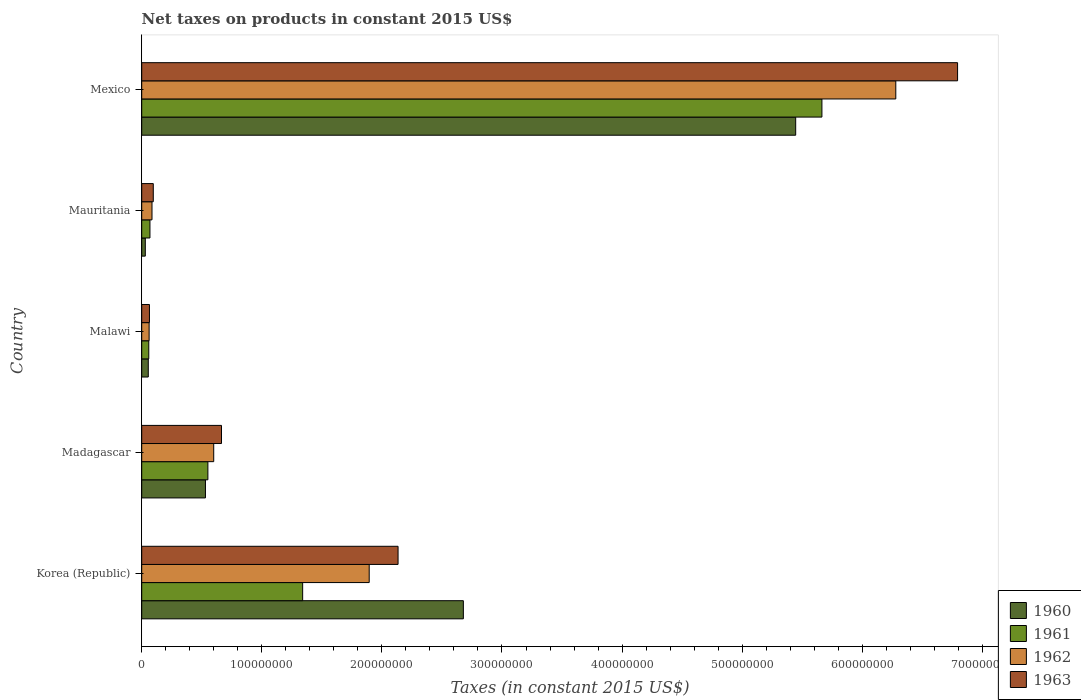How many groups of bars are there?
Ensure brevity in your answer.  5. Are the number of bars per tick equal to the number of legend labels?
Offer a very short reply. Yes. What is the label of the 4th group of bars from the top?
Your answer should be very brief. Madagascar. What is the net taxes on products in 1963 in Mexico?
Keep it short and to the point. 6.79e+08. Across all countries, what is the maximum net taxes on products in 1960?
Keep it short and to the point. 5.45e+08. Across all countries, what is the minimum net taxes on products in 1962?
Your answer should be very brief. 6.16e+06. In which country was the net taxes on products in 1963 minimum?
Offer a very short reply. Malawi. What is the total net taxes on products in 1961 in the graph?
Give a very brief answer. 7.68e+08. What is the difference between the net taxes on products in 1962 in Korea (Republic) and that in Mauritania?
Your answer should be very brief. 1.81e+08. What is the difference between the net taxes on products in 1961 in Korea (Republic) and the net taxes on products in 1962 in Madagascar?
Offer a terse response. 7.41e+07. What is the average net taxes on products in 1962 per country?
Make the answer very short. 1.78e+08. What is the difference between the net taxes on products in 1960 and net taxes on products in 1961 in Mexico?
Your response must be concise. -2.18e+07. In how many countries, is the net taxes on products in 1960 greater than 400000000 US$?
Your answer should be compact. 1. What is the ratio of the net taxes on products in 1962 in Korea (Republic) to that in Mexico?
Ensure brevity in your answer.  0.3. Is the net taxes on products in 1963 in Malawi less than that in Mexico?
Provide a short and direct response. Yes. Is the difference between the net taxes on products in 1960 in Korea (Republic) and Madagascar greater than the difference between the net taxes on products in 1961 in Korea (Republic) and Madagascar?
Offer a very short reply. Yes. What is the difference between the highest and the second highest net taxes on products in 1960?
Make the answer very short. 2.77e+08. What is the difference between the highest and the lowest net taxes on products in 1962?
Offer a very short reply. 6.22e+08. Is it the case that in every country, the sum of the net taxes on products in 1962 and net taxes on products in 1963 is greater than the sum of net taxes on products in 1960 and net taxes on products in 1961?
Your response must be concise. No. What does the 2nd bar from the top in Mexico represents?
Your answer should be compact. 1962. Is it the case that in every country, the sum of the net taxes on products in 1960 and net taxes on products in 1963 is greater than the net taxes on products in 1962?
Provide a short and direct response. Yes. Are all the bars in the graph horizontal?
Provide a short and direct response. Yes. How many countries are there in the graph?
Keep it short and to the point. 5. What is the difference between two consecutive major ticks on the X-axis?
Keep it short and to the point. 1.00e+08. What is the title of the graph?
Provide a succinct answer. Net taxes on products in constant 2015 US$. Does "1990" appear as one of the legend labels in the graph?
Make the answer very short. No. What is the label or title of the X-axis?
Ensure brevity in your answer.  Taxes (in constant 2015 US$). What is the label or title of the Y-axis?
Provide a short and direct response. Country. What is the Taxes (in constant 2015 US$) of 1960 in Korea (Republic)?
Give a very brief answer. 2.68e+08. What is the Taxes (in constant 2015 US$) in 1961 in Korea (Republic)?
Your answer should be very brief. 1.34e+08. What is the Taxes (in constant 2015 US$) in 1962 in Korea (Republic)?
Give a very brief answer. 1.89e+08. What is the Taxes (in constant 2015 US$) of 1963 in Korea (Republic)?
Your response must be concise. 2.13e+08. What is the Taxes (in constant 2015 US$) in 1960 in Madagascar?
Provide a short and direct response. 5.31e+07. What is the Taxes (in constant 2015 US$) in 1961 in Madagascar?
Make the answer very short. 5.51e+07. What is the Taxes (in constant 2015 US$) in 1962 in Madagascar?
Your answer should be very brief. 6.00e+07. What is the Taxes (in constant 2015 US$) of 1963 in Madagascar?
Give a very brief answer. 6.64e+07. What is the Taxes (in constant 2015 US$) of 1960 in Malawi?
Give a very brief answer. 5.46e+06. What is the Taxes (in constant 2015 US$) of 1961 in Malawi?
Your answer should be compact. 5.88e+06. What is the Taxes (in constant 2015 US$) of 1962 in Malawi?
Make the answer very short. 6.16e+06. What is the Taxes (in constant 2015 US$) of 1963 in Malawi?
Offer a very short reply. 6.44e+06. What is the Taxes (in constant 2015 US$) of 1960 in Mauritania?
Provide a short and direct response. 3.00e+06. What is the Taxes (in constant 2015 US$) in 1961 in Mauritania?
Your answer should be very brief. 6.85e+06. What is the Taxes (in constant 2015 US$) in 1962 in Mauritania?
Your answer should be very brief. 8.56e+06. What is the Taxes (in constant 2015 US$) in 1963 in Mauritania?
Give a very brief answer. 9.63e+06. What is the Taxes (in constant 2015 US$) of 1960 in Mexico?
Your response must be concise. 5.45e+08. What is the Taxes (in constant 2015 US$) in 1961 in Mexico?
Ensure brevity in your answer.  5.66e+08. What is the Taxes (in constant 2015 US$) of 1962 in Mexico?
Give a very brief answer. 6.28e+08. What is the Taxes (in constant 2015 US$) of 1963 in Mexico?
Give a very brief answer. 6.79e+08. Across all countries, what is the maximum Taxes (in constant 2015 US$) in 1960?
Make the answer very short. 5.45e+08. Across all countries, what is the maximum Taxes (in constant 2015 US$) in 1961?
Your answer should be compact. 5.66e+08. Across all countries, what is the maximum Taxes (in constant 2015 US$) of 1962?
Make the answer very short. 6.28e+08. Across all countries, what is the maximum Taxes (in constant 2015 US$) in 1963?
Provide a succinct answer. 6.79e+08. Across all countries, what is the minimum Taxes (in constant 2015 US$) in 1960?
Offer a terse response. 3.00e+06. Across all countries, what is the minimum Taxes (in constant 2015 US$) of 1961?
Ensure brevity in your answer.  5.88e+06. Across all countries, what is the minimum Taxes (in constant 2015 US$) of 1962?
Give a very brief answer. 6.16e+06. Across all countries, what is the minimum Taxes (in constant 2015 US$) in 1963?
Offer a terse response. 6.44e+06. What is the total Taxes (in constant 2015 US$) in 1960 in the graph?
Provide a succinct answer. 8.74e+08. What is the total Taxes (in constant 2015 US$) in 1961 in the graph?
Your answer should be very brief. 7.68e+08. What is the total Taxes (in constant 2015 US$) of 1962 in the graph?
Provide a succinct answer. 8.92e+08. What is the total Taxes (in constant 2015 US$) of 1963 in the graph?
Provide a short and direct response. 9.75e+08. What is the difference between the Taxes (in constant 2015 US$) in 1960 in Korea (Republic) and that in Madagascar?
Give a very brief answer. 2.15e+08. What is the difference between the Taxes (in constant 2015 US$) in 1961 in Korea (Republic) and that in Madagascar?
Give a very brief answer. 7.89e+07. What is the difference between the Taxes (in constant 2015 US$) of 1962 in Korea (Republic) and that in Madagascar?
Offer a very short reply. 1.29e+08. What is the difference between the Taxes (in constant 2015 US$) of 1963 in Korea (Republic) and that in Madagascar?
Provide a short and direct response. 1.47e+08. What is the difference between the Taxes (in constant 2015 US$) in 1960 in Korea (Republic) and that in Malawi?
Your response must be concise. 2.62e+08. What is the difference between the Taxes (in constant 2015 US$) of 1961 in Korea (Republic) and that in Malawi?
Ensure brevity in your answer.  1.28e+08. What is the difference between the Taxes (in constant 2015 US$) in 1962 in Korea (Republic) and that in Malawi?
Offer a very short reply. 1.83e+08. What is the difference between the Taxes (in constant 2015 US$) of 1963 in Korea (Republic) and that in Malawi?
Give a very brief answer. 2.07e+08. What is the difference between the Taxes (in constant 2015 US$) of 1960 in Korea (Republic) and that in Mauritania?
Offer a terse response. 2.65e+08. What is the difference between the Taxes (in constant 2015 US$) in 1961 in Korea (Republic) and that in Mauritania?
Provide a short and direct response. 1.27e+08. What is the difference between the Taxes (in constant 2015 US$) in 1962 in Korea (Republic) and that in Mauritania?
Offer a terse response. 1.81e+08. What is the difference between the Taxes (in constant 2015 US$) in 1963 in Korea (Republic) and that in Mauritania?
Ensure brevity in your answer.  2.04e+08. What is the difference between the Taxes (in constant 2015 US$) in 1960 in Korea (Republic) and that in Mexico?
Ensure brevity in your answer.  -2.77e+08. What is the difference between the Taxes (in constant 2015 US$) of 1961 in Korea (Republic) and that in Mexico?
Your response must be concise. -4.32e+08. What is the difference between the Taxes (in constant 2015 US$) in 1962 in Korea (Republic) and that in Mexico?
Offer a terse response. -4.38e+08. What is the difference between the Taxes (in constant 2015 US$) in 1963 in Korea (Republic) and that in Mexico?
Ensure brevity in your answer.  -4.66e+08. What is the difference between the Taxes (in constant 2015 US$) of 1960 in Madagascar and that in Malawi?
Keep it short and to the point. 4.76e+07. What is the difference between the Taxes (in constant 2015 US$) in 1961 in Madagascar and that in Malawi?
Ensure brevity in your answer.  4.92e+07. What is the difference between the Taxes (in constant 2015 US$) of 1962 in Madagascar and that in Malawi?
Your response must be concise. 5.38e+07. What is the difference between the Taxes (in constant 2015 US$) in 1963 in Madagascar and that in Malawi?
Offer a terse response. 6.00e+07. What is the difference between the Taxes (in constant 2015 US$) in 1960 in Madagascar and that in Mauritania?
Make the answer very short. 5.01e+07. What is the difference between the Taxes (in constant 2015 US$) in 1961 in Madagascar and that in Mauritania?
Give a very brief answer. 4.82e+07. What is the difference between the Taxes (in constant 2015 US$) of 1962 in Madagascar and that in Mauritania?
Your answer should be compact. 5.14e+07. What is the difference between the Taxes (in constant 2015 US$) of 1963 in Madagascar and that in Mauritania?
Offer a terse response. 5.68e+07. What is the difference between the Taxes (in constant 2015 US$) in 1960 in Madagascar and that in Mexico?
Offer a terse response. -4.91e+08. What is the difference between the Taxes (in constant 2015 US$) of 1961 in Madagascar and that in Mexico?
Your response must be concise. -5.11e+08. What is the difference between the Taxes (in constant 2015 US$) in 1962 in Madagascar and that in Mexico?
Your answer should be compact. -5.68e+08. What is the difference between the Taxes (in constant 2015 US$) of 1963 in Madagascar and that in Mexico?
Ensure brevity in your answer.  -6.13e+08. What is the difference between the Taxes (in constant 2015 US$) in 1960 in Malawi and that in Mauritania?
Give a very brief answer. 2.46e+06. What is the difference between the Taxes (in constant 2015 US$) in 1961 in Malawi and that in Mauritania?
Offer a very short reply. -9.67e+05. What is the difference between the Taxes (in constant 2015 US$) in 1962 in Malawi and that in Mauritania?
Your answer should be compact. -2.40e+06. What is the difference between the Taxes (in constant 2015 US$) in 1963 in Malawi and that in Mauritania?
Provide a short and direct response. -3.19e+06. What is the difference between the Taxes (in constant 2015 US$) in 1960 in Malawi and that in Mexico?
Ensure brevity in your answer.  -5.39e+08. What is the difference between the Taxes (in constant 2015 US$) in 1961 in Malawi and that in Mexico?
Make the answer very short. -5.61e+08. What is the difference between the Taxes (in constant 2015 US$) of 1962 in Malawi and that in Mexico?
Give a very brief answer. -6.22e+08. What is the difference between the Taxes (in constant 2015 US$) of 1963 in Malawi and that in Mexico?
Your answer should be very brief. -6.73e+08. What is the difference between the Taxes (in constant 2015 US$) in 1960 in Mauritania and that in Mexico?
Give a very brief answer. -5.42e+08. What is the difference between the Taxes (in constant 2015 US$) of 1961 in Mauritania and that in Mexico?
Your answer should be very brief. -5.60e+08. What is the difference between the Taxes (in constant 2015 US$) in 1962 in Mauritania and that in Mexico?
Your response must be concise. -6.19e+08. What is the difference between the Taxes (in constant 2015 US$) of 1963 in Mauritania and that in Mexico?
Provide a succinct answer. -6.70e+08. What is the difference between the Taxes (in constant 2015 US$) of 1960 in Korea (Republic) and the Taxes (in constant 2015 US$) of 1961 in Madagascar?
Ensure brevity in your answer.  2.13e+08. What is the difference between the Taxes (in constant 2015 US$) in 1960 in Korea (Republic) and the Taxes (in constant 2015 US$) in 1962 in Madagascar?
Your response must be concise. 2.08e+08. What is the difference between the Taxes (in constant 2015 US$) in 1960 in Korea (Republic) and the Taxes (in constant 2015 US$) in 1963 in Madagascar?
Keep it short and to the point. 2.01e+08. What is the difference between the Taxes (in constant 2015 US$) in 1961 in Korea (Republic) and the Taxes (in constant 2015 US$) in 1962 in Madagascar?
Provide a succinct answer. 7.41e+07. What is the difference between the Taxes (in constant 2015 US$) in 1961 in Korea (Republic) and the Taxes (in constant 2015 US$) in 1963 in Madagascar?
Ensure brevity in your answer.  6.76e+07. What is the difference between the Taxes (in constant 2015 US$) of 1962 in Korea (Republic) and the Taxes (in constant 2015 US$) of 1963 in Madagascar?
Your answer should be compact. 1.23e+08. What is the difference between the Taxes (in constant 2015 US$) of 1960 in Korea (Republic) and the Taxes (in constant 2015 US$) of 1961 in Malawi?
Offer a very short reply. 2.62e+08. What is the difference between the Taxes (in constant 2015 US$) in 1960 in Korea (Republic) and the Taxes (in constant 2015 US$) in 1962 in Malawi?
Offer a very short reply. 2.62e+08. What is the difference between the Taxes (in constant 2015 US$) in 1960 in Korea (Republic) and the Taxes (in constant 2015 US$) in 1963 in Malawi?
Your answer should be compact. 2.61e+08. What is the difference between the Taxes (in constant 2015 US$) in 1961 in Korea (Republic) and the Taxes (in constant 2015 US$) in 1962 in Malawi?
Your answer should be very brief. 1.28e+08. What is the difference between the Taxes (in constant 2015 US$) of 1961 in Korea (Republic) and the Taxes (in constant 2015 US$) of 1963 in Malawi?
Provide a succinct answer. 1.28e+08. What is the difference between the Taxes (in constant 2015 US$) in 1962 in Korea (Republic) and the Taxes (in constant 2015 US$) in 1963 in Malawi?
Offer a very short reply. 1.83e+08. What is the difference between the Taxes (in constant 2015 US$) of 1960 in Korea (Republic) and the Taxes (in constant 2015 US$) of 1961 in Mauritania?
Provide a succinct answer. 2.61e+08. What is the difference between the Taxes (in constant 2015 US$) of 1960 in Korea (Republic) and the Taxes (in constant 2015 US$) of 1962 in Mauritania?
Provide a short and direct response. 2.59e+08. What is the difference between the Taxes (in constant 2015 US$) in 1960 in Korea (Republic) and the Taxes (in constant 2015 US$) in 1963 in Mauritania?
Your answer should be compact. 2.58e+08. What is the difference between the Taxes (in constant 2015 US$) in 1961 in Korea (Republic) and the Taxes (in constant 2015 US$) in 1962 in Mauritania?
Offer a terse response. 1.25e+08. What is the difference between the Taxes (in constant 2015 US$) in 1961 in Korea (Republic) and the Taxes (in constant 2015 US$) in 1963 in Mauritania?
Offer a very short reply. 1.24e+08. What is the difference between the Taxes (in constant 2015 US$) of 1962 in Korea (Republic) and the Taxes (in constant 2015 US$) of 1963 in Mauritania?
Your response must be concise. 1.80e+08. What is the difference between the Taxes (in constant 2015 US$) in 1960 in Korea (Republic) and the Taxes (in constant 2015 US$) in 1961 in Mexico?
Provide a succinct answer. -2.99e+08. What is the difference between the Taxes (in constant 2015 US$) in 1960 in Korea (Republic) and the Taxes (in constant 2015 US$) in 1962 in Mexico?
Offer a terse response. -3.60e+08. What is the difference between the Taxes (in constant 2015 US$) in 1960 in Korea (Republic) and the Taxes (in constant 2015 US$) in 1963 in Mexico?
Offer a very short reply. -4.12e+08. What is the difference between the Taxes (in constant 2015 US$) of 1961 in Korea (Republic) and the Taxes (in constant 2015 US$) of 1962 in Mexico?
Keep it short and to the point. -4.94e+08. What is the difference between the Taxes (in constant 2015 US$) of 1961 in Korea (Republic) and the Taxes (in constant 2015 US$) of 1963 in Mexico?
Your response must be concise. -5.45e+08. What is the difference between the Taxes (in constant 2015 US$) in 1962 in Korea (Republic) and the Taxes (in constant 2015 US$) in 1963 in Mexico?
Your response must be concise. -4.90e+08. What is the difference between the Taxes (in constant 2015 US$) of 1960 in Madagascar and the Taxes (in constant 2015 US$) of 1961 in Malawi?
Give a very brief answer. 4.72e+07. What is the difference between the Taxes (in constant 2015 US$) of 1960 in Madagascar and the Taxes (in constant 2015 US$) of 1962 in Malawi?
Keep it short and to the point. 4.69e+07. What is the difference between the Taxes (in constant 2015 US$) of 1960 in Madagascar and the Taxes (in constant 2015 US$) of 1963 in Malawi?
Provide a short and direct response. 4.66e+07. What is the difference between the Taxes (in constant 2015 US$) of 1961 in Madagascar and the Taxes (in constant 2015 US$) of 1962 in Malawi?
Your answer should be compact. 4.89e+07. What is the difference between the Taxes (in constant 2015 US$) in 1961 in Madagascar and the Taxes (in constant 2015 US$) in 1963 in Malawi?
Make the answer very short. 4.87e+07. What is the difference between the Taxes (in constant 2015 US$) of 1962 in Madagascar and the Taxes (in constant 2015 US$) of 1963 in Malawi?
Your response must be concise. 5.35e+07. What is the difference between the Taxes (in constant 2015 US$) of 1960 in Madagascar and the Taxes (in constant 2015 US$) of 1961 in Mauritania?
Provide a succinct answer. 4.62e+07. What is the difference between the Taxes (in constant 2015 US$) of 1960 in Madagascar and the Taxes (in constant 2015 US$) of 1962 in Mauritania?
Ensure brevity in your answer.  4.45e+07. What is the difference between the Taxes (in constant 2015 US$) of 1960 in Madagascar and the Taxes (in constant 2015 US$) of 1963 in Mauritania?
Your response must be concise. 4.34e+07. What is the difference between the Taxes (in constant 2015 US$) of 1961 in Madagascar and the Taxes (in constant 2015 US$) of 1962 in Mauritania?
Your response must be concise. 4.65e+07. What is the difference between the Taxes (in constant 2015 US$) in 1961 in Madagascar and the Taxes (in constant 2015 US$) in 1963 in Mauritania?
Your response must be concise. 4.55e+07. What is the difference between the Taxes (in constant 2015 US$) of 1962 in Madagascar and the Taxes (in constant 2015 US$) of 1963 in Mauritania?
Your response must be concise. 5.03e+07. What is the difference between the Taxes (in constant 2015 US$) in 1960 in Madagascar and the Taxes (in constant 2015 US$) in 1961 in Mexico?
Give a very brief answer. -5.13e+08. What is the difference between the Taxes (in constant 2015 US$) in 1960 in Madagascar and the Taxes (in constant 2015 US$) in 1962 in Mexico?
Ensure brevity in your answer.  -5.75e+08. What is the difference between the Taxes (in constant 2015 US$) in 1960 in Madagascar and the Taxes (in constant 2015 US$) in 1963 in Mexico?
Your answer should be compact. -6.26e+08. What is the difference between the Taxes (in constant 2015 US$) of 1961 in Madagascar and the Taxes (in constant 2015 US$) of 1962 in Mexico?
Provide a short and direct response. -5.73e+08. What is the difference between the Taxes (in constant 2015 US$) in 1961 in Madagascar and the Taxes (in constant 2015 US$) in 1963 in Mexico?
Offer a very short reply. -6.24e+08. What is the difference between the Taxes (in constant 2015 US$) in 1962 in Madagascar and the Taxes (in constant 2015 US$) in 1963 in Mexico?
Keep it short and to the point. -6.19e+08. What is the difference between the Taxes (in constant 2015 US$) in 1960 in Malawi and the Taxes (in constant 2015 US$) in 1961 in Mauritania?
Ensure brevity in your answer.  -1.39e+06. What is the difference between the Taxes (in constant 2015 US$) in 1960 in Malawi and the Taxes (in constant 2015 US$) in 1962 in Mauritania?
Keep it short and to the point. -3.10e+06. What is the difference between the Taxes (in constant 2015 US$) in 1960 in Malawi and the Taxes (in constant 2015 US$) in 1963 in Mauritania?
Offer a very short reply. -4.17e+06. What is the difference between the Taxes (in constant 2015 US$) of 1961 in Malawi and the Taxes (in constant 2015 US$) of 1962 in Mauritania?
Offer a very short reply. -2.68e+06. What is the difference between the Taxes (in constant 2015 US$) in 1961 in Malawi and the Taxes (in constant 2015 US$) in 1963 in Mauritania?
Your answer should be very brief. -3.75e+06. What is the difference between the Taxes (in constant 2015 US$) in 1962 in Malawi and the Taxes (in constant 2015 US$) in 1963 in Mauritania?
Keep it short and to the point. -3.47e+06. What is the difference between the Taxes (in constant 2015 US$) in 1960 in Malawi and the Taxes (in constant 2015 US$) in 1961 in Mexico?
Your answer should be very brief. -5.61e+08. What is the difference between the Taxes (in constant 2015 US$) in 1960 in Malawi and the Taxes (in constant 2015 US$) in 1962 in Mexico?
Offer a terse response. -6.22e+08. What is the difference between the Taxes (in constant 2015 US$) of 1960 in Malawi and the Taxes (in constant 2015 US$) of 1963 in Mexico?
Keep it short and to the point. -6.74e+08. What is the difference between the Taxes (in constant 2015 US$) in 1961 in Malawi and the Taxes (in constant 2015 US$) in 1962 in Mexico?
Make the answer very short. -6.22e+08. What is the difference between the Taxes (in constant 2015 US$) of 1961 in Malawi and the Taxes (in constant 2015 US$) of 1963 in Mexico?
Offer a terse response. -6.73e+08. What is the difference between the Taxes (in constant 2015 US$) in 1962 in Malawi and the Taxes (in constant 2015 US$) in 1963 in Mexico?
Ensure brevity in your answer.  -6.73e+08. What is the difference between the Taxes (in constant 2015 US$) of 1960 in Mauritania and the Taxes (in constant 2015 US$) of 1961 in Mexico?
Offer a very short reply. -5.63e+08. What is the difference between the Taxes (in constant 2015 US$) in 1960 in Mauritania and the Taxes (in constant 2015 US$) in 1962 in Mexico?
Provide a short and direct response. -6.25e+08. What is the difference between the Taxes (in constant 2015 US$) of 1960 in Mauritania and the Taxes (in constant 2015 US$) of 1963 in Mexico?
Provide a succinct answer. -6.76e+08. What is the difference between the Taxes (in constant 2015 US$) of 1961 in Mauritania and the Taxes (in constant 2015 US$) of 1962 in Mexico?
Your answer should be compact. -6.21e+08. What is the difference between the Taxes (in constant 2015 US$) in 1961 in Mauritania and the Taxes (in constant 2015 US$) in 1963 in Mexico?
Provide a succinct answer. -6.73e+08. What is the difference between the Taxes (in constant 2015 US$) of 1962 in Mauritania and the Taxes (in constant 2015 US$) of 1963 in Mexico?
Provide a short and direct response. -6.71e+08. What is the average Taxes (in constant 2015 US$) of 1960 per country?
Offer a terse response. 1.75e+08. What is the average Taxes (in constant 2015 US$) of 1961 per country?
Provide a short and direct response. 1.54e+08. What is the average Taxes (in constant 2015 US$) of 1962 per country?
Offer a terse response. 1.78e+08. What is the average Taxes (in constant 2015 US$) of 1963 per country?
Your response must be concise. 1.95e+08. What is the difference between the Taxes (in constant 2015 US$) in 1960 and Taxes (in constant 2015 US$) in 1961 in Korea (Republic)?
Your answer should be very brief. 1.34e+08. What is the difference between the Taxes (in constant 2015 US$) in 1960 and Taxes (in constant 2015 US$) in 1962 in Korea (Republic)?
Your answer should be very brief. 7.84e+07. What is the difference between the Taxes (in constant 2015 US$) in 1960 and Taxes (in constant 2015 US$) in 1963 in Korea (Republic)?
Ensure brevity in your answer.  5.44e+07. What is the difference between the Taxes (in constant 2015 US$) in 1961 and Taxes (in constant 2015 US$) in 1962 in Korea (Republic)?
Your response must be concise. -5.54e+07. What is the difference between the Taxes (in constant 2015 US$) of 1961 and Taxes (in constant 2015 US$) of 1963 in Korea (Republic)?
Give a very brief answer. -7.94e+07. What is the difference between the Taxes (in constant 2015 US$) of 1962 and Taxes (in constant 2015 US$) of 1963 in Korea (Republic)?
Keep it short and to the point. -2.40e+07. What is the difference between the Taxes (in constant 2015 US$) of 1960 and Taxes (in constant 2015 US$) of 1961 in Madagascar?
Make the answer very short. -2.03e+06. What is the difference between the Taxes (in constant 2015 US$) in 1960 and Taxes (in constant 2015 US$) in 1962 in Madagascar?
Your answer should be compact. -6.89e+06. What is the difference between the Taxes (in constant 2015 US$) in 1960 and Taxes (in constant 2015 US$) in 1963 in Madagascar?
Give a very brief answer. -1.34e+07. What is the difference between the Taxes (in constant 2015 US$) of 1961 and Taxes (in constant 2015 US$) of 1962 in Madagascar?
Your response must be concise. -4.86e+06. What is the difference between the Taxes (in constant 2015 US$) of 1961 and Taxes (in constant 2015 US$) of 1963 in Madagascar?
Your answer should be very brief. -1.13e+07. What is the difference between the Taxes (in constant 2015 US$) of 1962 and Taxes (in constant 2015 US$) of 1963 in Madagascar?
Offer a very short reply. -6.48e+06. What is the difference between the Taxes (in constant 2015 US$) in 1960 and Taxes (in constant 2015 US$) in 1961 in Malawi?
Ensure brevity in your answer.  -4.20e+05. What is the difference between the Taxes (in constant 2015 US$) in 1960 and Taxes (in constant 2015 US$) in 1962 in Malawi?
Provide a succinct answer. -7.00e+05. What is the difference between the Taxes (in constant 2015 US$) of 1960 and Taxes (in constant 2015 US$) of 1963 in Malawi?
Provide a succinct answer. -9.80e+05. What is the difference between the Taxes (in constant 2015 US$) of 1961 and Taxes (in constant 2015 US$) of 1962 in Malawi?
Your response must be concise. -2.80e+05. What is the difference between the Taxes (in constant 2015 US$) in 1961 and Taxes (in constant 2015 US$) in 1963 in Malawi?
Provide a short and direct response. -5.60e+05. What is the difference between the Taxes (in constant 2015 US$) in 1962 and Taxes (in constant 2015 US$) in 1963 in Malawi?
Offer a very short reply. -2.80e+05. What is the difference between the Taxes (in constant 2015 US$) in 1960 and Taxes (in constant 2015 US$) in 1961 in Mauritania?
Your answer should be compact. -3.85e+06. What is the difference between the Taxes (in constant 2015 US$) in 1960 and Taxes (in constant 2015 US$) in 1962 in Mauritania?
Provide a short and direct response. -5.56e+06. What is the difference between the Taxes (in constant 2015 US$) of 1960 and Taxes (in constant 2015 US$) of 1963 in Mauritania?
Your response must be concise. -6.63e+06. What is the difference between the Taxes (in constant 2015 US$) in 1961 and Taxes (in constant 2015 US$) in 1962 in Mauritania?
Offer a very short reply. -1.71e+06. What is the difference between the Taxes (in constant 2015 US$) of 1961 and Taxes (in constant 2015 US$) of 1963 in Mauritania?
Provide a succinct answer. -2.78e+06. What is the difference between the Taxes (in constant 2015 US$) of 1962 and Taxes (in constant 2015 US$) of 1963 in Mauritania?
Offer a very short reply. -1.07e+06. What is the difference between the Taxes (in constant 2015 US$) in 1960 and Taxes (in constant 2015 US$) in 1961 in Mexico?
Your answer should be very brief. -2.18e+07. What is the difference between the Taxes (in constant 2015 US$) in 1960 and Taxes (in constant 2015 US$) in 1962 in Mexico?
Offer a terse response. -8.34e+07. What is the difference between the Taxes (in constant 2015 US$) in 1960 and Taxes (in constant 2015 US$) in 1963 in Mexico?
Offer a very short reply. -1.35e+08. What is the difference between the Taxes (in constant 2015 US$) in 1961 and Taxes (in constant 2015 US$) in 1962 in Mexico?
Make the answer very short. -6.15e+07. What is the difference between the Taxes (in constant 2015 US$) of 1961 and Taxes (in constant 2015 US$) of 1963 in Mexico?
Your answer should be very brief. -1.13e+08. What is the difference between the Taxes (in constant 2015 US$) in 1962 and Taxes (in constant 2015 US$) in 1963 in Mexico?
Your answer should be very brief. -5.14e+07. What is the ratio of the Taxes (in constant 2015 US$) in 1960 in Korea (Republic) to that in Madagascar?
Provide a succinct answer. 5.05. What is the ratio of the Taxes (in constant 2015 US$) in 1961 in Korea (Republic) to that in Madagascar?
Give a very brief answer. 2.43. What is the ratio of the Taxes (in constant 2015 US$) of 1962 in Korea (Republic) to that in Madagascar?
Offer a terse response. 3.16. What is the ratio of the Taxes (in constant 2015 US$) in 1963 in Korea (Republic) to that in Madagascar?
Your answer should be very brief. 3.21. What is the ratio of the Taxes (in constant 2015 US$) of 1960 in Korea (Republic) to that in Malawi?
Ensure brevity in your answer.  49.05. What is the ratio of the Taxes (in constant 2015 US$) in 1961 in Korea (Republic) to that in Malawi?
Provide a short and direct response. 22.79. What is the ratio of the Taxes (in constant 2015 US$) of 1962 in Korea (Republic) to that in Malawi?
Keep it short and to the point. 30.75. What is the ratio of the Taxes (in constant 2015 US$) in 1963 in Korea (Republic) to that in Malawi?
Make the answer very short. 33.15. What is the ratio of the Taxes (in constant 2015 US$) in 1960 in Korea (Republic) to that in Mauritania?
Offer a very short reply. 89.41. What is the ratio of the Taxes (in constant 2015 US$) of 1961 in Korea (Republic) to that in Mauritania?
Make the answer very short. 19.57. What is the ratio of the Taxes (in constant 2015 US$) of 1962 in Korea (Republic) to that in Mauritania?
Your answer should be very brief. 22.13. What is the ratio of the Taxes (in constant 2015 US$) in 1963 in Korea (Republic) to that in Mauritania?
Your answer should be compact. 22.17. What is the ratio of the Taxes (in constant 2015 US$) in 1960 in Korea (Republic) to that in Mexico?
Provide a short and direct response. 0.49. What is the ratio of the Taxes (in constant 2015 US$) in 1961 in Korea (Republic) to that in Mexico?
Your answer should be compact. 0.24. What is the ratio of the Taxes (in constant 2015 US$) of 1962 in Korea (Republic) to that in Mexico?
Make the answer very short. 0.3. What is the ratio of the Taxes (in constant 2015 US$) of 1963 in Korea (Republic) to that in Mexico?
Give a very brief answer. 0.31. What is the ratio of the Taxes (in constant 2015 US$) of 1960 in Madagascar to that in Malawi?
Your answer should be very brief. 9.72. What is the ratio of the Taxes (in constant 2015 US$) in 1961 in Madagascar to that in Malawi?
Provide a succinct answer. 9.37. What is the ratio of the Taxes (in constant 2015 US$) of 1962 in Madagascar to that in Malawi?
Offer a terse response. 9.73. What is the ratio of the Taxes (in constant 2015 US$) in 1963 in Madagascar to that in Malawi?
Ensure brevity in your answer.  10.32. What is the ratio of the Taxes (in constant 2015 US$) of 1960 in Madagascar to that in Mauritania?
Ensure brevity in your answer.  17.72. What is the ratio of the Taxes (in constant 2015 US$) in 1961 in Madagascar to that in Mauritania?
Give a very brief answer. 8.05. What is the ratio of the Taxes (in constant 2015 US$) of 1962 in Madagascar to that in Mauritania?
Your response must be concise. 7. What is the ratio of the Taxes (in constant 2015 US$) in 1963 in Madagascar to that in Mauritania?
Give a very brief answer. 6.9. What is the ratio of the Taxes (in constant 2015 US$) in 1960 in Madagascar to that in Mexico?
Provide a succinct answer. 0.1. What is the ratio of the Taxes (in constant 2015 US$) of 1961 in Madagascar to that in Mexico?
Offer a very short reply. 0.1. What is the ratio of the Taxes (in constant 2015 US$) in 1962 in Madagascar to that in Mexico?
Your answer should be very brief. 0.1. What is the ratio of the Taxes (in constant 2015 US$) of 1963 in Madagascar to that in Mexico?
Ensure brevity in your answer.  0.1. What is the ratio of the Taxes (in constant 2015 US$) of 1960 in Malawi to that in Mauritania?
Your answer should be compact. 1.82. What is the ratio of the Taxes (in constant 2015 US$) in 1961 in Malawi to that in Mauritania?
Give a very brief answer. 0.86. What is the ratio of the Taxes (in constant 2015 US$) of 1962 in Malawi to that in Mauritania?
Give a very brief answer. 0.72. What is the ratio of the Taxes (in constant 2015 US$) of 1963 in Malawi to that in Mauritania?
Provide a succinct answer. 0.67. What is the ratio of the Taxes (in constant 2015 US$) in 1960 in Malawi to that in Mexico?
Your answer should be very brief. 0.01. What is the ratio of the Taxes (in constant 2015 US$) in 1961 in Malawi to that in Mexico?
Your response must be concise. 0.01. What is the ratio of the Taxes (in constant 2015 US$) in 1962 in Malawi to that in Mexico?
Offer a terse response. 0.01. What is the ratio of the Taxes (in constant 2015 US$) in 1963 in Malawi to that in Mexico?
Your answer should be very brief. 0.01. What is the ratio of the Taxes (in constant 2015 US$) in 1960 in Mauritania to that in Mexico?
Provide a succinct answer. 0.01. What is the ratio of the Taxes (in constant 2015 US$) in 1961 in Mauritania to that in Mexico?
Offer a very short reply. 0.01. What is the ratio of the Taxes (in constant 2015 US$) of 1962 in Mauritania to that in Mexico?
Give a very brief answer. 0.01. What is the ratio of the Taxes (in constant 2015 US$) in 1963 in Mauritania to that in Mexico?
Make the answer very short. 0.01. What is the difference between the highest and the second highest Taxes (in constant 2015 US$) of 1960?
Offer a very short reply. 2.77e+08. What is the difference between the highest and the second highest Taxes (in constant 2015 US$) of 1961?
Provide a short and direct response. 4.32e+08. What is the difference between the highest and the second highest Taxes (in constant 2015 US$) in 1962?
Keep it short and to the point. 4.38e+08. What is the difference between the highest and the second highest Taxes (in constant 2015 US$) in 1963?
Provide a succinct answer. 4.66e+08. What is the difference between the highest and the lowest Taxes (in constant 2015 US$) of 1960?
Offer a very short reply. 5.42e+08. What is the difference between the highest and the lowest Taxes (in constant 2015 US$) of 1961?
Offer a very short reply. 5.61e+08. What is the difference between the highest and the lowest Taxes (in constant 2015 US$) of 1962?
Provide a short and direct response. 6.22e+08. What is the difference between the highest and the lowest Taxes (in constant 2015 US$) in 1963?
Your answer should be very brief. 6.73e+08. 